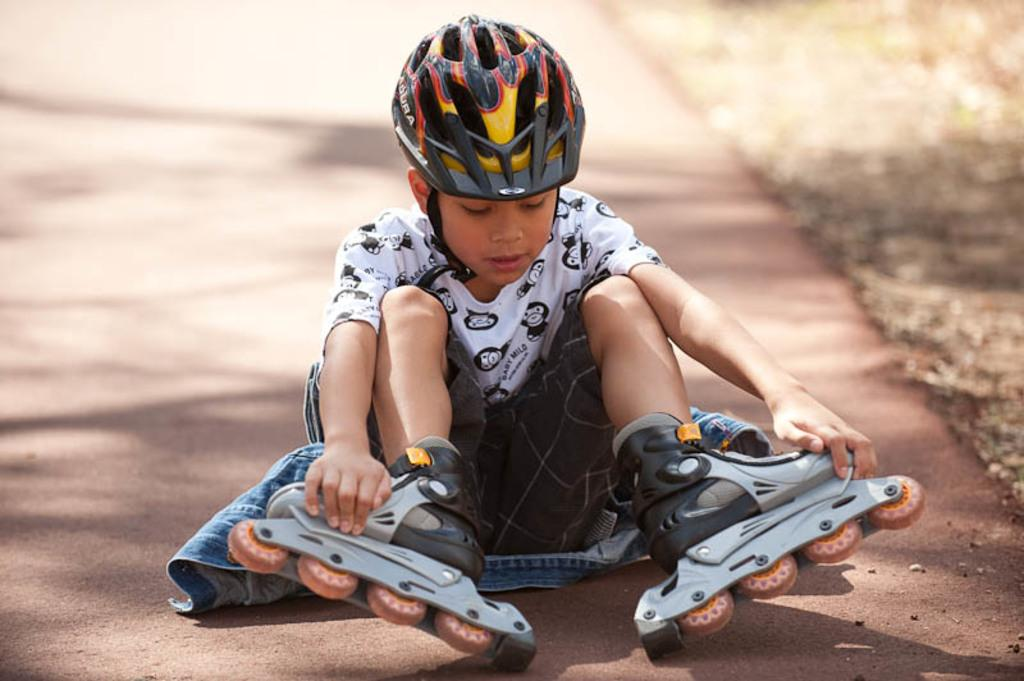What is the main subject of the image? There is a boy in the image. What is the boy wearing on his upper body? The boy is wearing a white t-shirt. What is the boy wearing on his head? The boy is wearing a helmet on his head. What is the boy wearing on his legs? The boy is wearing skates on his legs. Where is the boy sitting in the image? The boy is sitting on the road. What type of vegetation can be seen beside the road? There is grass beside the road in the image. What is the reason for the boy's sudden turn in the image? There is no indication of a sudden turn in the image; the boy is sitting on the road with his skates on. Can you tell me how many cows are present on the farm in the image? There is no farm or cows present in the image; it features a boy sitting on the road with a helmet and skates. 